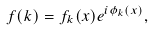<formula> <loc_0><loc_0><loc_500><loc_500>f ( { k } ) = f _ { k } ( x ) e ^ { i \phi _ { k } ( x ) } ,</formula> 